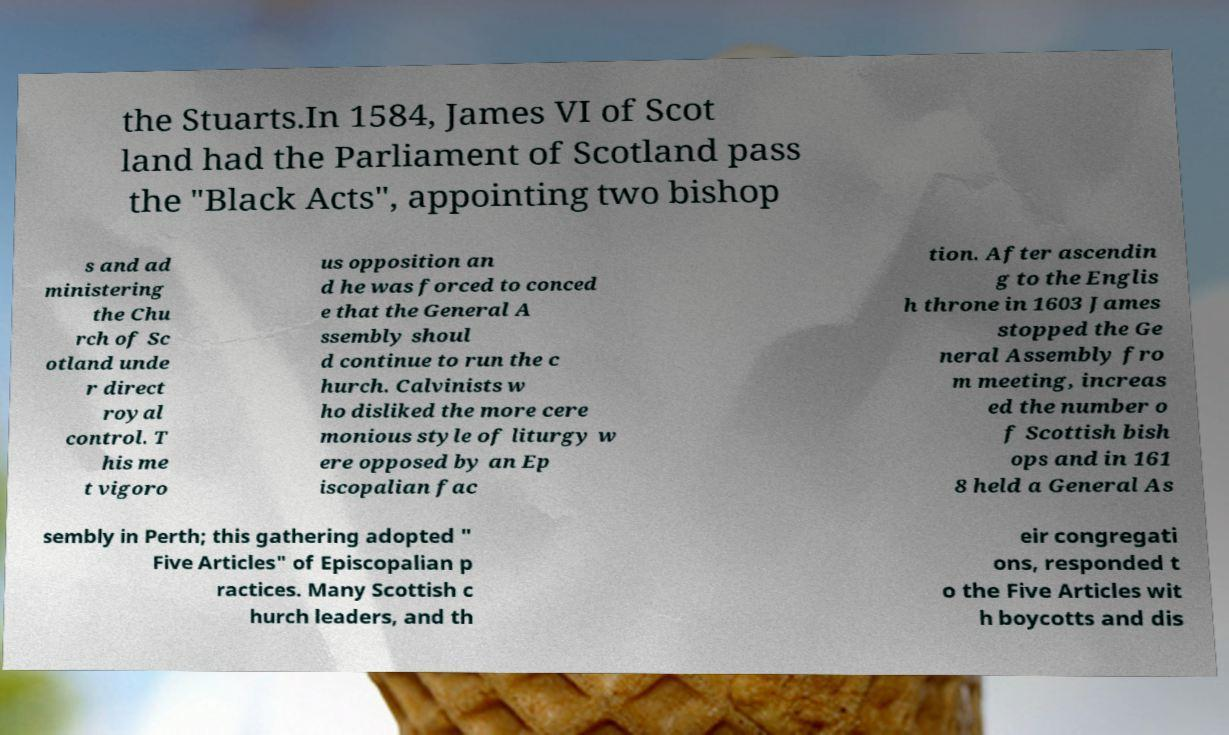Could you assist in decoding the text presented in this image and type it out clearly? the Stuarts.In 1584, James VI of Scot land had the Parliament of Scotland pass the "Black Acts", appointing two bishop s and ad ministering the Chu rch of Sc otland unde r direct royal control. T his me t vigoro us opposition an d he was forced to conced e that the General A ssembly shoul d continue to run the c hurch. Calvinists w ho disliked the more cere monious style of liturgy w ere opposed by an Ep iscopalian fac tion. After ascendin g to the Englis h throne in 1603 James stopped the Ge neral Assembly fro m meeting, increas ed the number o f Scottish bish ops and in 161 8 held a General As sembly in Perth; this gathering adopted " Five Articles" of Episcopalian p ractices. Many Scottish c hurch leaders, and th eir congregati ons, responded t o the Five Articles wit h boycotts and dis 